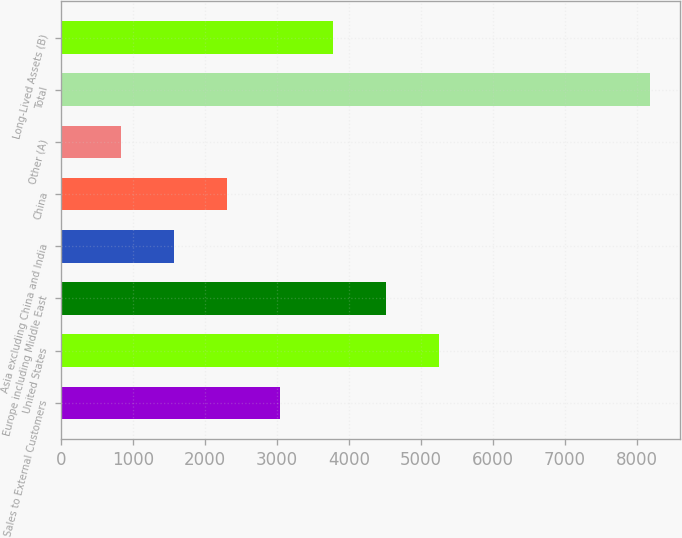<chart> <loc_0><loc_0><loc_500><loc_500><bar_chart><fcel>Sales to External Customers<fcel>United States<fcel>Europe including Middle East<fcel>Asia excluding China and India<fcel>China<fcel>Other (A)<fcel>Total<fcel>Long-Lived Assets (B)<nl><fcel>3036.79<fcel>5244.28<fcel>4508.45<fcel>1565.13<fcel>2300.96<fcel>829.3<fcel>8187.6<fcel>3772.62<nl></chart> 